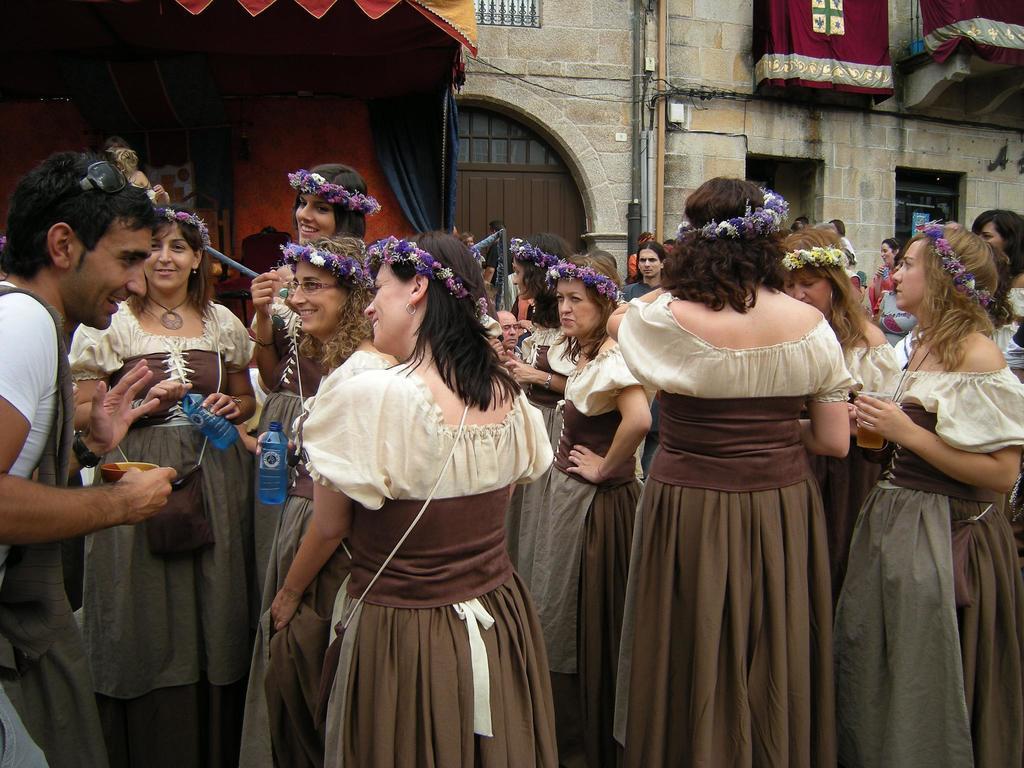Please provide a concise description of this image. In the image we can see there are many people standing and few of them are wearing the same clothes and the flower crown. On the left side, we can see a man wearing a wristwatch and he is holding a bowl in the hand. Here we can see the building, cable wire and windows of the building. 